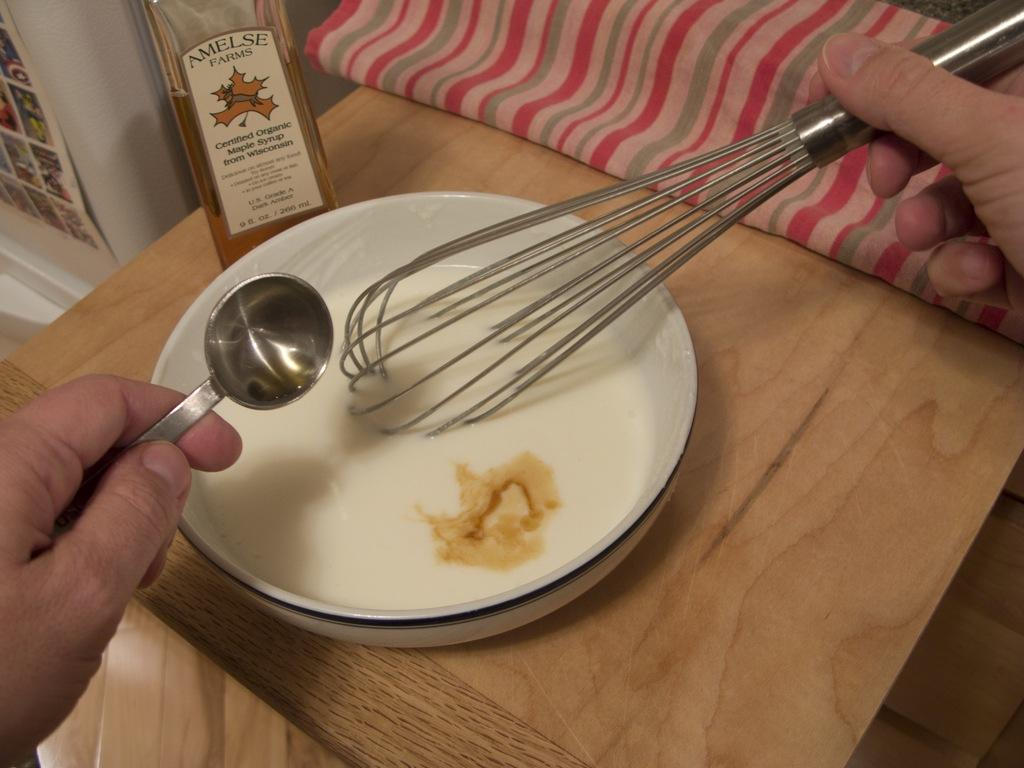What is being held by the person's hand in the image? There is a person's hand holding a spoon in the image. What kitchen utensil can be seen in the image? There is a whisk in the image. What is covering the table in the image? There is a cloth on the table in the image. What is on the table in the image? There is a bottle and a bowl with food in it on the table in the image. What can be seen in the background of the image? There is a poster in the background of the image. Which direction is the person facing in the image? The provided facts do not mention the direction the person is facing, so it cannot be determined from the image. What type of power is being generated by the bottle in the image? There is no indication that the bottle is generating any power in the image. 